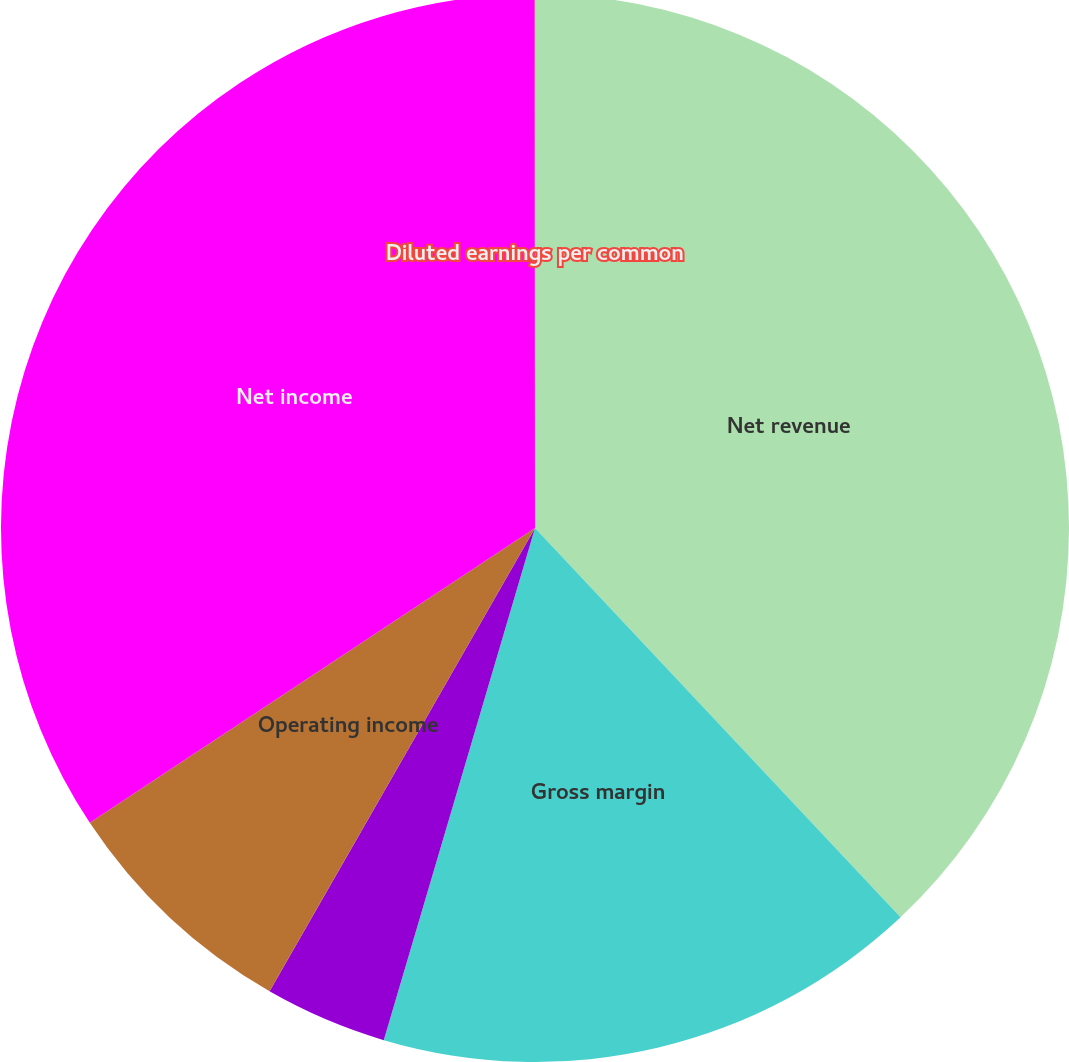Convert chart to OTSL. <chart><loc_0><loc_0><loc_500><loc_500><pie_chart><fcel>Net revenue<fcel>Gross margin<fcel>Gross margin percentage<fcel>Operating income<fcel>Net income<fcel>Diluted earnings per common<nl><fcel>38.0%<fcel>16.57%<fcel>3.71%<fcel>7.41%<fcel>34.3%<fcel>0.01%<nl></chart> 